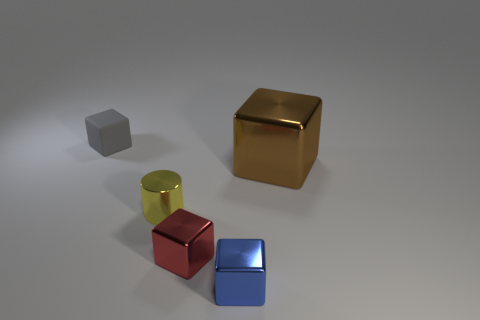Are there any other things that are the same material as the small gray object?
Your answer should be very brief. No. Is there any other thing that has the same size as the brown metallic thing?
Provide a short and direct response. No. The tiny object that is behind the metallic block behind the small yellow metallic cylinder that is on the left side of the blue metallic block is what shape?
Provide a succinct answer. Cube. What number of tiny gray objects are the same material as the small gray block?
Provide a succinct answer. 0. What number of large cubes are to the right of the block that is left of the metallic cylinder?
Give a very brief answer. 1. Do the shiny cube behind the small yellow metallic cylinder and the metallic object in front of the small red metal block have the same color?
Make the answer very short. No. What shape is the shiny thing that is both on the right side of the small yellow thing and behind the small red block?
Provide a short and direct response. Cube. Are there any small metallic objects that have the same shape as the big metal thing?
Keep it short and to the point. Yes. There is a red metallic thing that is the same size as the rubber cube; what shape is it?
Your answer should be compact. Cube. What is the material of the blue thing?
Your answer should be compact. Metal. 